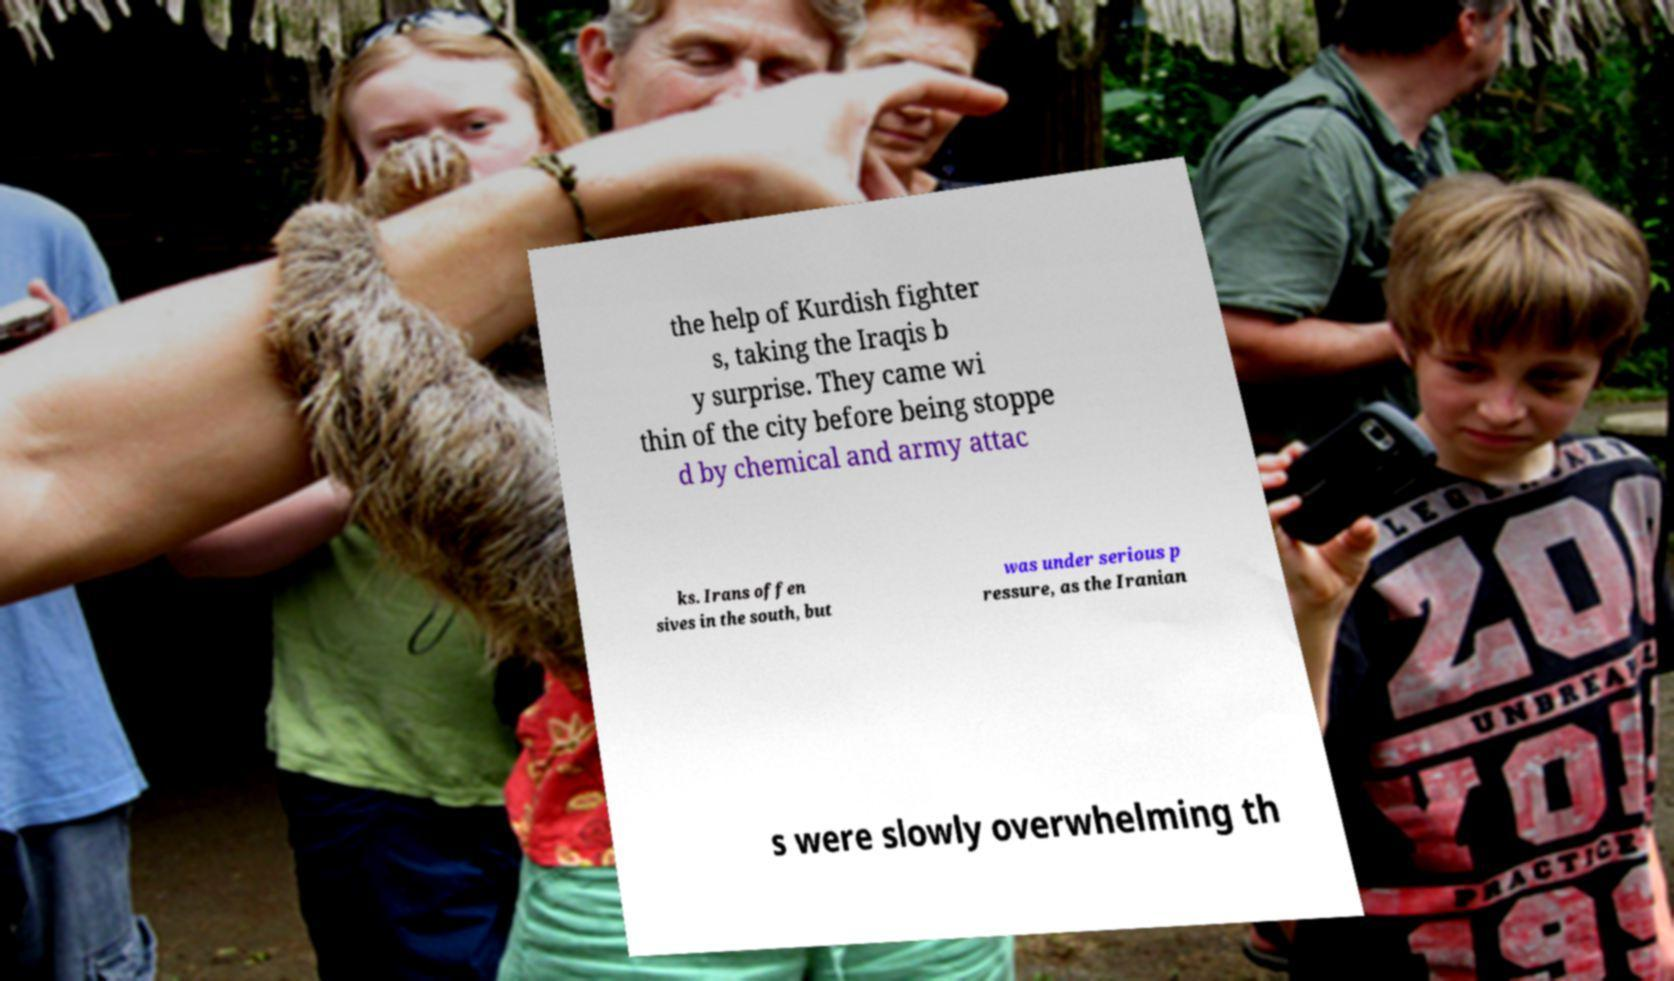Could you extract and type out the text from this image? the help of Kurdish fighter s, taking the Iraqis b y surprise. They came wi thin of the city before being stoppe d by chemical and army attac ks. Irans offen sives in the south, but was under serious p ressure, as the Iranian s were slowly overwhelming th 